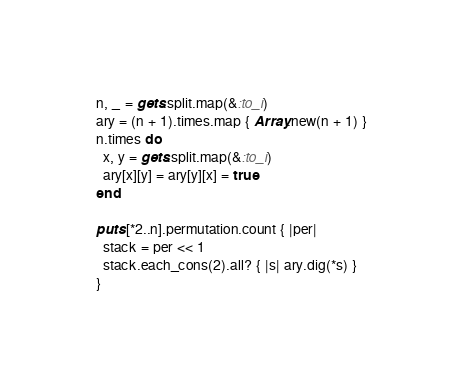<code> <loc_0><loc_0><loc_500><loc_500><_Ruby_>n, _ = gets.split.map(&:to_i)
ary = (n + 1).times.map { Array.new(n + 1) }
n.times do
  x, y = gets.split.map(&:to_i)
  ary[x][y] = ary[y][x] = true
end

puts [*2..n].permutation.count { |per|
  stack = per << 1
  stack.each_cons(2).all? { |s| ary.dig(*s) }
}
</code> 